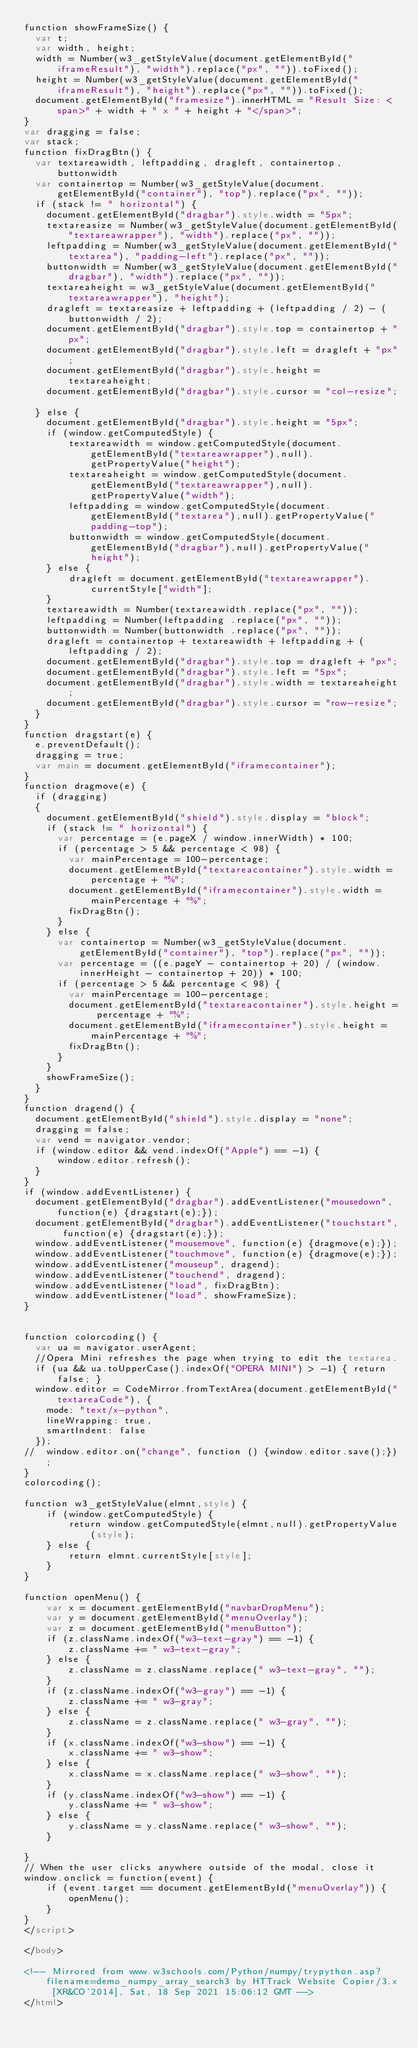<code> <loc_0><loc_0><loc_500><loc_500><_HTML_>function showFrameSize() {
  var t;
  var width, height;
  width = Number(w3_getStyleValue(document.getElementById("iframeResult"), "width").replace("px", "")).toFixed();
  height = Number(w3_getStyleValue(document.getElementById("iframeResult"), "height").replace("px", "")).toFixed();
  document.getElementById("framesize").innerHTML = "Result Size: <span>" + width + " x " + height + "</span>";
}
var dragging = false;
var stack;
function fixDragBtn() {
  var textareawidth, leftpadding, dragleft, containertop, buttonwidth
  var containertop = Number(w3_getStyleValue(document.getElementById("container"), "top").replace("px", ""));
  if (stack != " horizontal") {
    document.getElementById("dragbar").style.width = "5px";    
    textareasize = Number(w3_getStyleValue(document.getElementById("textareawrapper"), "width").replace("px", ""));
    leftpadding = Number(w3_getStyleValue(document.getElementById("textarea"), "padding-left").replace("px", ""));
    buttonwidth = Number(w3_getStyleValue(document.getElementById("dragbar"), "width").replace("px", ""));
    textareaheight = w3_getStyleValue(document.getElementById("textareawrapper"), "height");
    dragleft = textareasize + leftpadding + (leftpadding / 2) - (buttonwidth / 2);
    document.getElementById("dragbar").style.top = containertop + "px";
    document.getElementById("dragbar").style.left = dragleft + "px";
    document.getElementById("dragbar").style.height = textareaheight;
    document.getElementById("dragbar").style.cursor = "col-resize";
    
  } else {
    document.getElementById("dragbar").style.height = "5px";
    if (window.getComputedStyle) {
        textareawidth = window.getComputedStyle(document.getElementById("textareawrapper"),null).getPropertyValue("height");
        textareaheight = window.getComputedStyle(document.getElementById("textareawrapper"),null).getPropertyValue("width");
        leftpadding = window.getComputedStyle(document.getElementById("textarea"),null).getPropertyValue("padding-top");
        buttonwidth = window.getComputedStyle(document.getElementById("dragbar"),null).getPropertyValue("height");
    } else {
        dragleft = document.getElementById("textareawrapper").currentStyle["width"];
    }
    textareawidth = Number(textareawidth.replace("px", ""));
    leftpadding = Number(leftpadding .replace("px", ""));
    buttonwidth = Number(buttonwidth .replace("px", ""));
    dragleft = containertop + textareawidth + leftpadding + (leftpadding / 2);
    document.getElementById("dragbar").style.top = dragleft + "px";
    document.getElementById("dragbar").style.left = "5px";
    document.getElementById("dragbar").style.width = textareaheight;
    document.getElementById("dragbar").style.cursor = "row-resize";        
  }
}
function dragstart(e) {
  e.preventDefault();
  dragging = true;
  var main = document.getElementById("iframecontainer");
}
function dragmove(e) {
  if (dragging) 
  {
    document.getElementById("shield").style.display = "block";        
    if (stack != " horizontal") {
      var percentage = (e.pageX / window.innerWidth) * 100;
      if (percentage > 5 && percentage < 98) {
        var mainPercentage = 100-percentage;
        document.getElementById("textareacontainer").style.width = percentage + "%";
        document.getElementById("iframecontainer").style.width = mainPercentage + "%";
        fixDragBtn();
      }
    } else {
      var containertop = Number(w3_getStyleValue(document.getElementById("container"), "top").replace("px", ""));
      var percentage = ((e.pageY - containertop + 20) / (window.innerHeight - containertop + 20)) * 100;
      if (percentage > 5 && percentage < 98) {
        var mainPercentage = 100-percentage;
        document.getElementById("textareacontainer").style.height = percentage + "%";
        document.getElementById("iframecontainer").style.height = mainPercentage + "%";
        fixDragBtn();
      }
    }
    showFrameSize();    
  }
}
function dragend() {
  document.getElementById("shield").style.display = "none";
  dragging = false;
  var vend = navigator.vendor;
  if (window.editor && vend.indexOf("Apple") == -1) {
      window.editor.refresh();
  }
}
if (window.addEventListener) {              
  document.getElementById("dragbar").addEventListener("mousedown", function(e) {dragstart(e);});
  document.getElementById("dragbar").addEventListener("touchstart", function(e) {dragstart(e);});
  window.addEventListener("mousemove", function(e) {dragmove(e);});
  window.addEventListener("touchmove", function(e) {dragmove(e);});
  window.addEventListener("mouseup", dragend);
  window.addEventListener("touchend", dragend);
  window.addEventListener("load", fixDragBtn);
  window.addEventListener("load", showFrameSize);
}


function colorcoding() {
  var ua = navigator.userAgent;
  //Opera Mini refreshes the page when trying to edit the textarea.
  if (ua && ua.toUpperCase().indexOf("OPERA MINI") > -1) { return false; }
  window.editor = CodeMirror.fromTextArea(document.getElementById("textareaCode"), {
    mode: "text/x-python",
    lineWrapping: true,
    smartIndent: false
  });
//  window.editor.on("change", function () {window.editor.save();});
}
colorcoding();

function w3_getStyleValue(elmnt,style) {
    if (window.getComputedStyle) {
        return window.getComputedStyle(elmnt,null).getPropertyValue(style);
    } else {
        return elmnt.currentStyle[style];
    }
}

function openMenu() {
    var x = document.getElementById("navbarDropMenu");
    var y = document.getElementById("menuOverlay");
    var z = document.getElementById("menuButton");
    if (z.className.indexOf("w3-text-gray") == -1) {
        z.className += " w3-text-gray";
    } else { 
        z.className = z.className.replace(" w3-text-gray", "");
    }
    if (z.className.indexOf("w3-gray") == -1) {
        z.className += " w3-gray";
    } else { 
        z.className = z.className.replace(" w3-gray", "");
    }
    if (x.className.indexOf("w3-show") == -1) {
        x.className += " w3-show";
    } else { 
        x.className = x.className.replace(" w3-show", "");
    }
    if (y.className.indexOf("w3-show") == -1) {
        y.className += " w3-show";
    } else { 
        y.className = y.className.replace(" w3-show", "");
    }

}
// When the user clicks anywhere outside of the modal, close it
window.onclick = function(event) {
    if (event.target == document.getElementById("menuOverlay")) {
        openMenu();
    } 
}
</script>

</body>

<!-- Mirrored from www.w3schools.com/Python/numpy/trypython.asp?filename=demo_numpy_array_search3 by HTTrack Website Copier/3.x [XR&CO'2014], Sat, 18 Sep 2021 15:06:12 GMT -->
</html></code> 